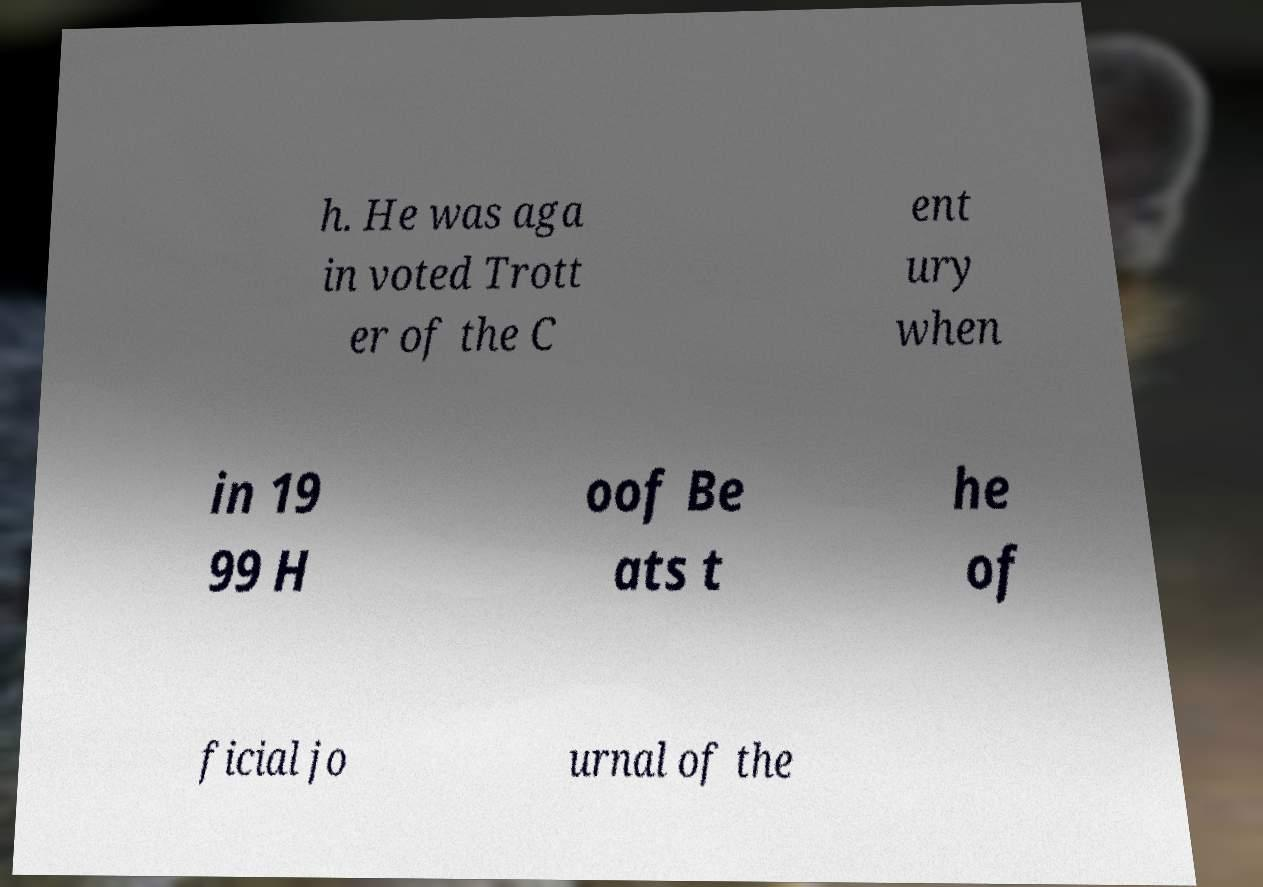There's text embedded in this image that I need extracted. Can you transcribe it verbatim? h. He was aga in voted Trott er of the C ent ury when in 19 99 H oof Be ats t he of ficial jo urnal of the 